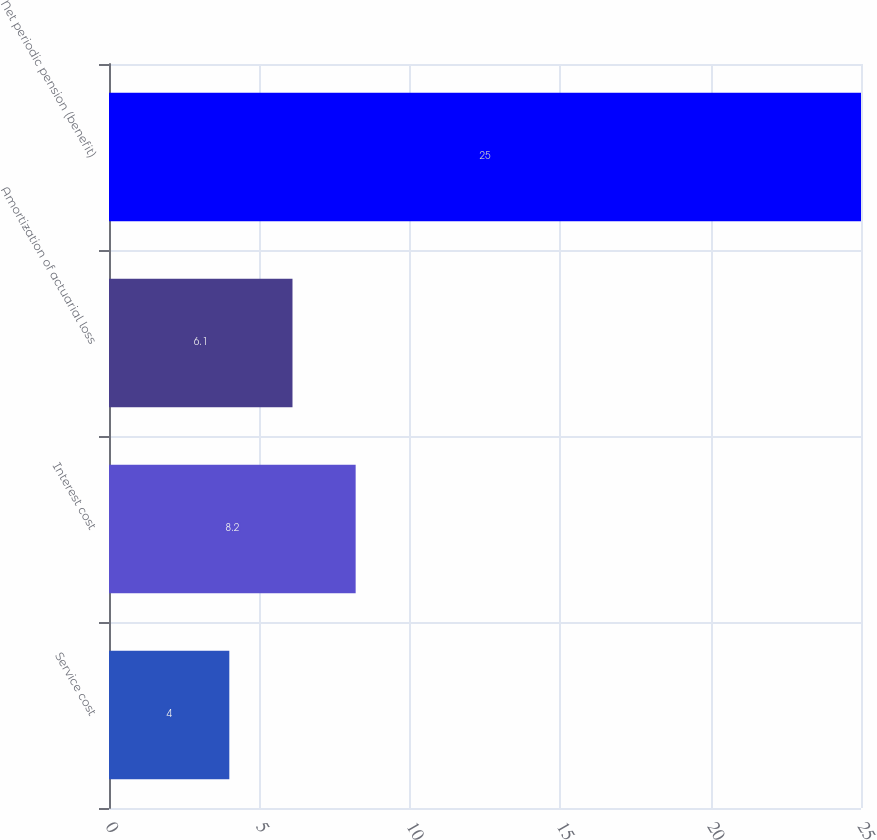Convert chart to OTSL. <chart><loc_0><loc_0><loc_500><loc_500><bar_chart><fcel>Service cost<fcel>Interest cost<fcel>Amortization of actuarial loss<fcel>Net periodic pension (benefit)<nl><fcel>4<fcel>8.2<fcel>6.1<fcel>25<nl></chart> 